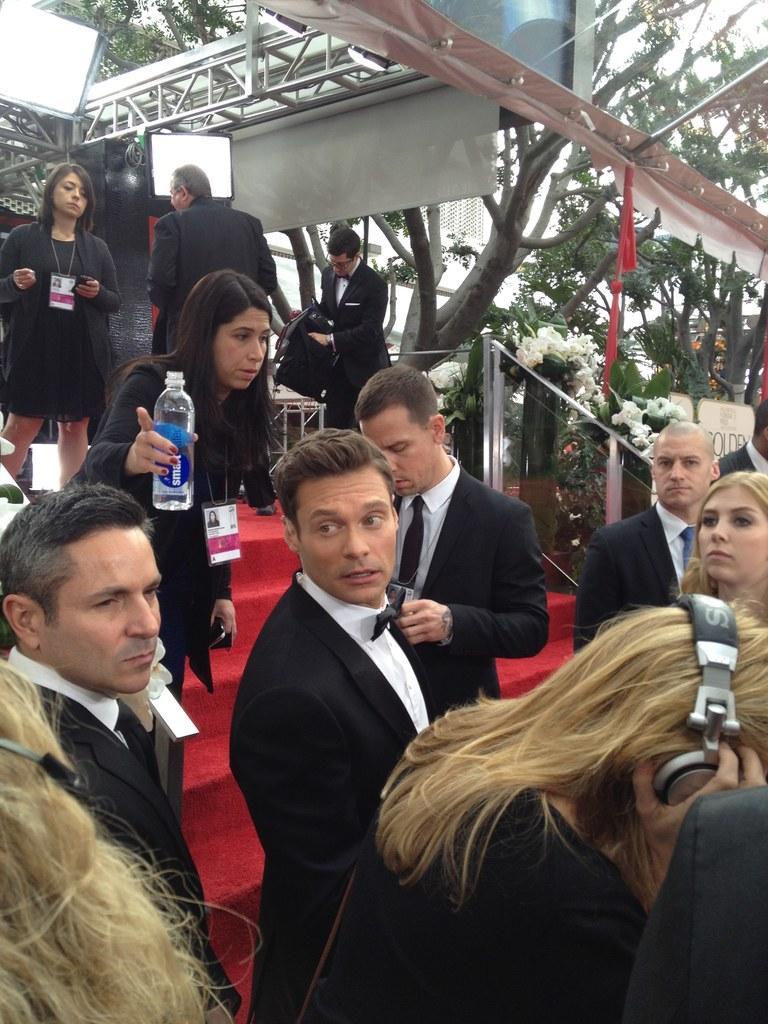Describe this image in one or two sentences. In the foreground I can see a crowd on the steps, bottle, metal rods, screen and tent. In the background I can see trees, flowering plants, lights and the sky. This image is taken may be during a day. 